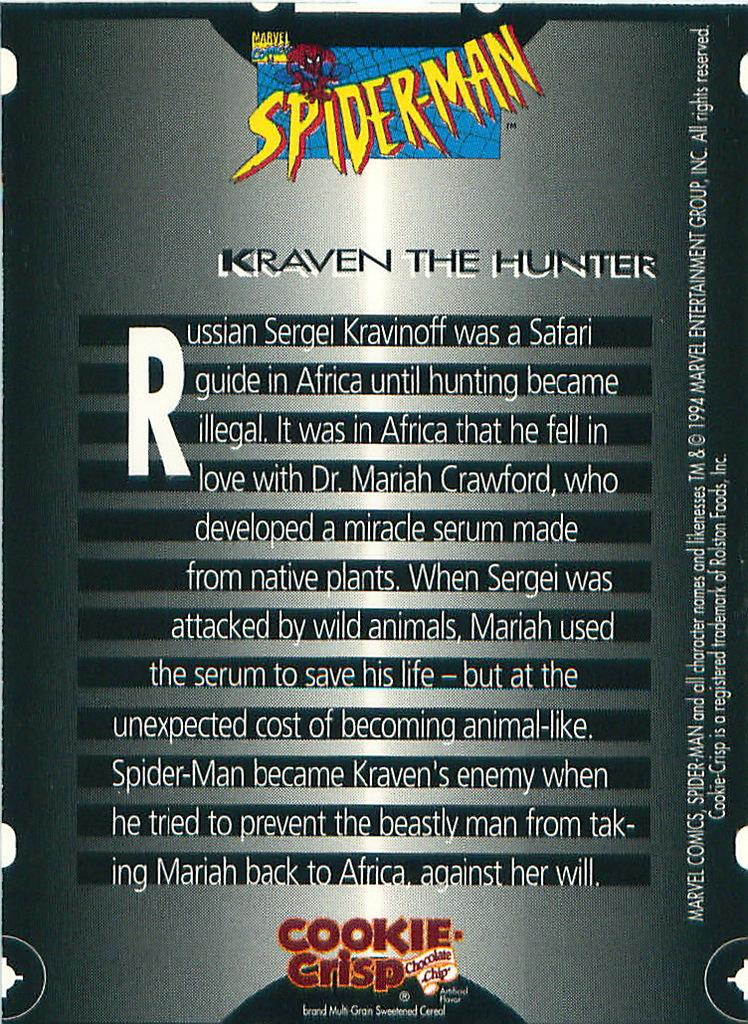What is featured in the image? There is a poster in the image. What is the color of the poster? The poster is black in color. What type of text is present on the poster? The text on the poster is edited. Are there any symbols or images on the poster? Yes, there are logos on the poster. What decision is depicted on the poster? There is no decision depicted on the poster; it features edited text and logos. Can you see any ducks on the poster? There are no ducks present on the poster; it only contains edited text and logos. 